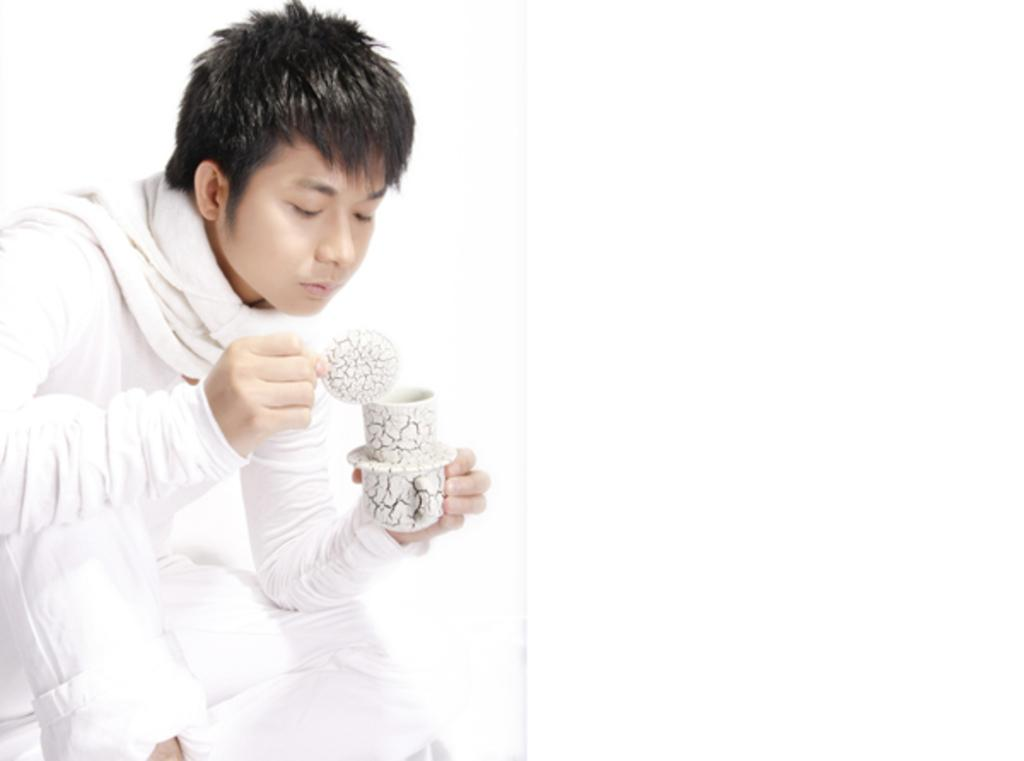Who is present in the image? There is a man in the image. What is the man wearing? The man is wearing a white dress. What is the man holding in his hand? The man is holding two cups in his hand. What is the color of the background in the image? The background of the image is white. What type of glove is the man wearing in the image? The man is not wearing a glove in the image; he is wearing a white dress. Is there a beast visible in the image? There is no beast present in the image. 